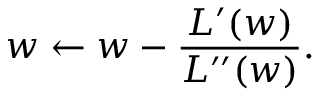Convert formula to latex. <formula><loc_0><loc_0><loc_500><loc_500>w \leftarrow w - \frac { L ^ { \prime } ( w ) } { L ^ { \prime \prime } ( w ) } .</formula> 